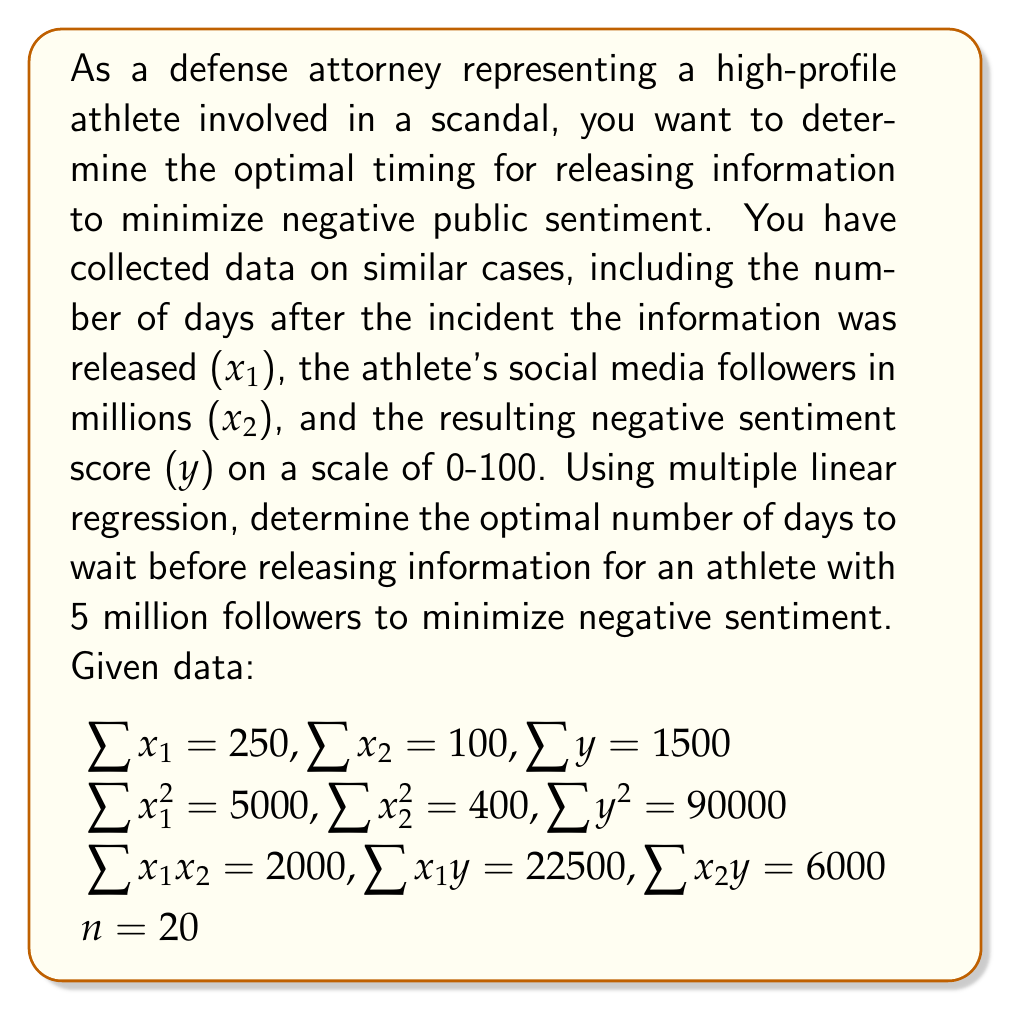Give your solution to this math problem. To solve this problem, we'll use multiple linear regression to model the relationship between the variables and then find the optimal timing.

Step 1: Set up the multiple linear regression equation
$$y = \beta_0 + \beta_1x_1 + \beta_2x_2 + \epsilon$$

Step 2: Calculate the coefficients using the normal equations
$$\begin{bmatrix} 
\sum x_1^2 & \sum x_1x_2 & \sum x_1 \\
\sum x_1x_2 & \sum x_2^2 & \sum x_2 \\
\sum x_1 & \sum x_2 & n
\end{bmatrix}
\begin{bmatrix}
\beta_1 \\
\beta_2 \\
\beta_0
\end{bmatrix} =
\begin{bmatrix}
\sum x_1y \\
\sum x_2y \\
\sum y
\end{bmatrix}$$

Substituting the given values:

$$\begin{bmatrix} 
5000 & 2000 & 250 \\
2000 & 400 & 100 \\
250 & 100 & 20
\end{bmatrix}
\begin{bmatrix}
\beta_1 \\
\beta_2 \\
\beta_0
\end{bmatrix} =
\begin{bmatrix}
22500 \\
6000 \\
1500
\end{bmatrix}$$

Step 3: Solve the system of equations (using matrix operations or other methods)
$$\beta_1 \approx -0.5$$
$$\beta_2 \approx 10$$
$$\beta_0 \approx 50$$

Step 4: Write the regression equation
$$y = 50 - 0.5x_1 + 10x_2$$

Step 5: To minimize negative sentiment, we want to minimize $y$. Since $x_2$ (followers) is fixed at 5 million, we need to maximize $x_1$ (days) within reasonable bounds.

Step 6: Set a reasonable upper bound for $x_1$, say 30 days, and calculate $y$
$$y = 50 - 0.5(30) + 10(5) = 85$$

Therefore, the optimal timing is to wait the maximum reasonable time, which we set at 30 days.
Answer: The optimal number of days to wait before releasing information for an athlete with 5 million followers to minimize negative sentiment is 30 days. 